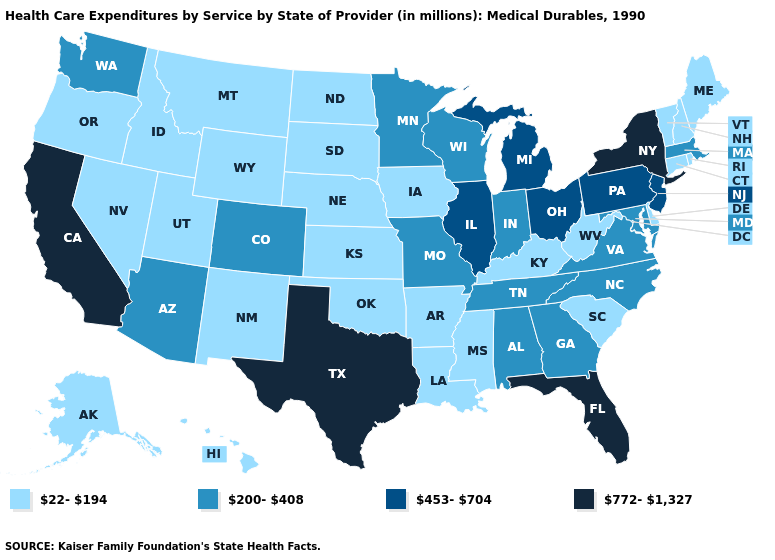Which states hav the highest value in the South?
Answer briefly. Florida, Texas. What is the lowest value in states that border West Virginia?
Write a very short answer. 22-194. Among the states that border Tennessee , does Virginia have the lowest value?
Write a very short answer. No. What is the highest value in the South ?
Quick response, please. 772-1,327. Does the map have missing data?
Answer briefly. No. What is the lowest value in the South?
Write a very short answer. 22-194. Name the states that have a value in the range 200-408?
Be succinct. Alabama, Arizona, Colorado, Georgia, Indiana, Maryland, Massachusetts, Minnesota, Missouri, North Carolina, Tennessee, Virginia, Washington, Wisconsin. Is the legend a continuous bar?
Be succinct. No. What is the highest value in states that border Oklahoma?
Write a very short answer. 772-1,327. Which states hav the highest value in the MidWest?
Give a very brief answer. Illinois, Michigan, Ohio. Does the map have missing data?
Keep it brief. No. What is the value of Mississippi?
Short answer required. 22-194. What is the value of Michigan?
Give a very brief answer. 453-704. Among the states that border Vermont , which have the highest value?
Keep it brief. New York. Name the states that have a value in the range 200-408?
Be succinct. Alabama, Arizona, Colorado, Georgia, Indiana, Maryland, Massachusetts, Minnesota, Missouri, North Carolina, Tennessee, Virginia, Washington, Wisconsin. 